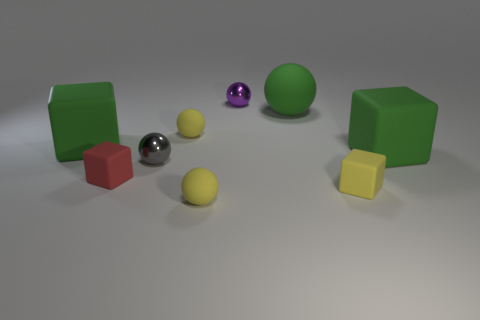Is there any other thing of the same color as the big matte sphere?
Provide a short and direct response. Yes. There is a green thing that is both in front of the large sphere and to the right of the tiny purple thing; what material is it made of?
Ensure brevity in your answer.  Rubber. What number of other objects are the same size as the gray metallic ball?
Your answer should be compact. 5. There is a ball on the right side of the purple shiny thing; is its color the same as the large thing that is on the left side of the gray shiny object?
Provide a short and direct response. Yes. What is the size of the green sphere?
Provide a succinct answer. Large. What size is the red cube in front of the gray metallic sphere?
Ensure brevity in your answer.  Small. The big green rubber object that is both in front of the green matte ball and to the right of the purple metal thing has what shape?
Give a very brief answer. Cube. How many other objects are there of the same shape as the small purple metallic thing?
Offer a terse response. 4. What is the color of the other shiny sphere that is the same size as the purple shiny ball?
Your response must be concise. Gray. How many objects are big matte balls or tiny yellow rubber blocks?
Your answer should be compact. 2. 